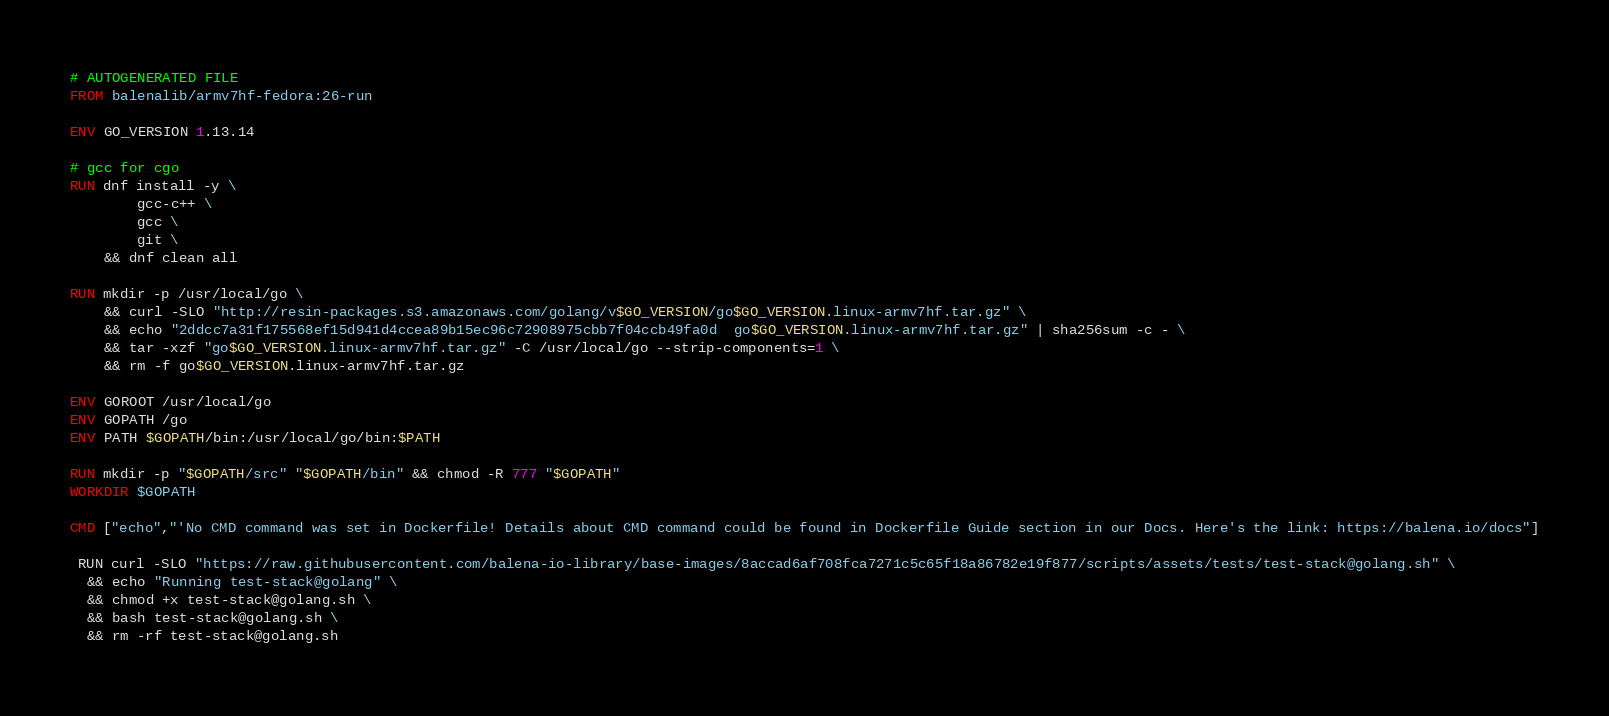<code> <loc_0><loc_0><loc_500><loc_500><_Dockerfile_># AUTOGENERATED FILE
FROM balenalib/armv7hf-fedora:26-run

ENV GO_VERSION 1.13.14

# gcc for cgo
RUN dnf install -y \
		gcc-c++ \
		gcc \
		git \
	&& dnf clean all

RUN mkdir -p /usr/local/go \
	&& curl -SLO "http://resin-packages.s3.amazonaws.com/golang/v$GO_VERSION/go$GO_VERSION.linux-armv7hf.tar.gz" \
	&& echo "2ddcc7a31f175568ef15d941d4ccea89b15ec96c72908975cbb7f04ccb49fa0d  go$GO_VERSION.linux-armv7hf.tar.gz" | sha256sum -c - \
	&& tar -xzf "go$GO_VERSION.linux-armv7hf.tar.gz" -C /usr/local/go --strip-components=1 \
	&& rm -f go$GO_VERSION.linux-armv7hf.tar.gz

ENV GOROOT /usr/local/go
ENV GOPATH /go
ENV PATH $GOPATH/bin:/usr/local/go/bin:$PATH

RUN mkdir -p "$GOPATH/src" "$GOPATH/bin" && chmod -R 777 "$GOPATH"
WORKDIR $GOPATH

CMD ["echo","'No CMD command was set in Dockerfile! Details about CMD command could be found in Dockerfile Guide section in our Docs. Here's the link: https://balena.io/docs"]

 RUN curl -SLO "https://raw.githubusercontent.com/balena-io-library/base-images/8accad6af708fca7271c5c65f18a86782e19f877/scripts/assets/tests/test-stack@golang.sh" \
  && echo "Running test-stack@golang" \
  && chmod +x test-stack@golang.sh \
  && bash test-stack@golang.sh \
  && rm -rf test-stack@golang.sh 
</code> 